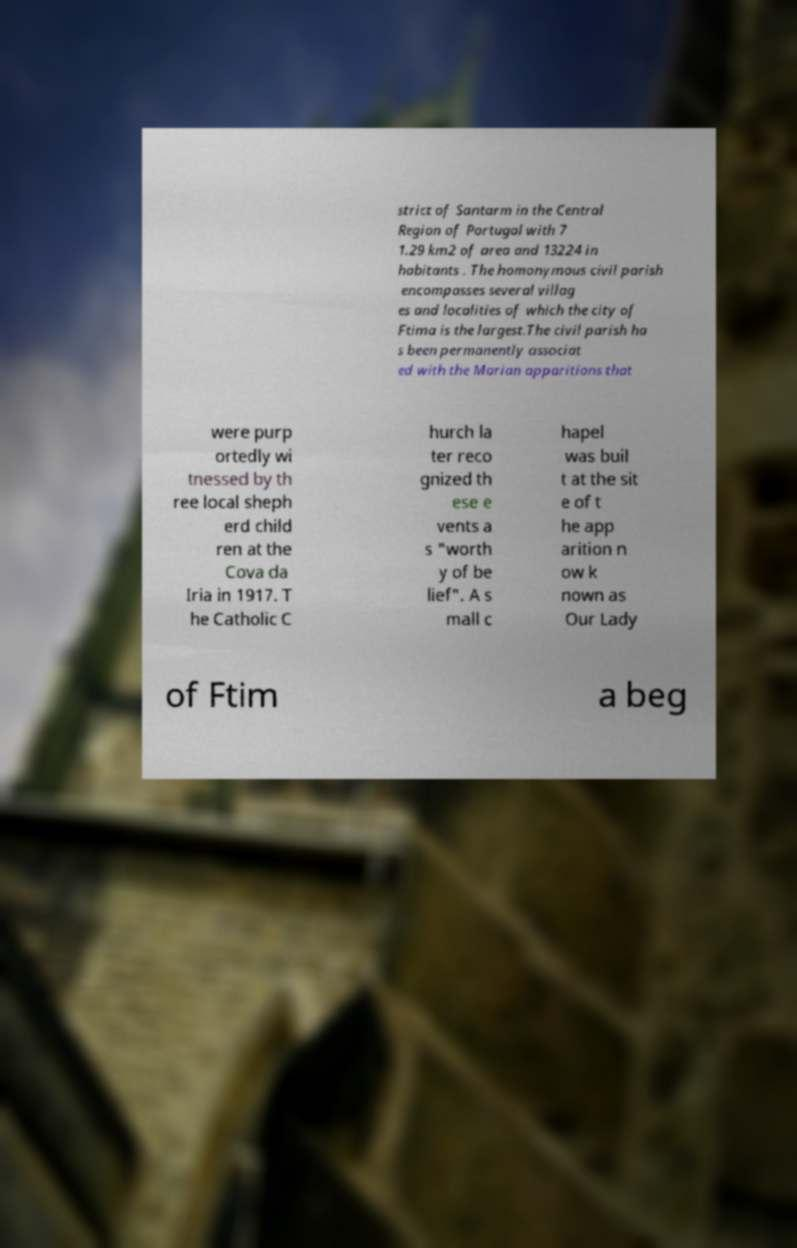What messages or text are displayed in this image? I need them in a readable, typed format. strict of Santarm in the Central Region of Portugal with 7 1.29 km2 of area and 13224 in habitants . The homonymous civil parish encompasses several villag es and localities of which the city of Ftima is the largest.The civil parish ha s been permanently associat ed with the Marian apparitions that were purp ortedly wi tnessed by th ree local sheph erd child ren at the Cova da Iria in 1917. T he Catholic C hurch la ter reco gnized th ese e vents a s "worth y of be lief". A s mall c hapel was buil t at the sit e of t he app arition n ow k nown as Our Lady of Ftim a beg 